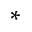<formula> <loc_0><loc_0><loc_500><loc_500>^ { * }</formula> 